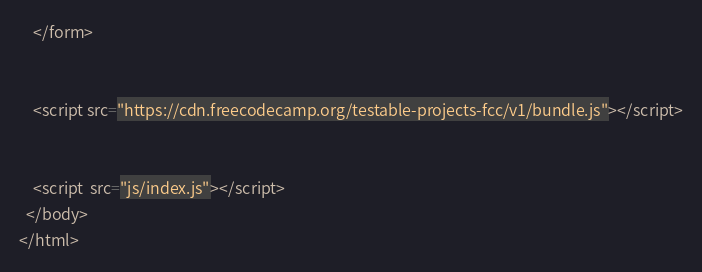Convert code to text. <code><loc_0><loc_0><loc_500><loc_500><_HTML_>


    </form>


    <script src="https://cdn.freecodecamp.org/testable-projects-fcc/v1/bundle.js"></script>


    <script  src="js/index.js"></script>
  </body>
</html>
</code> 